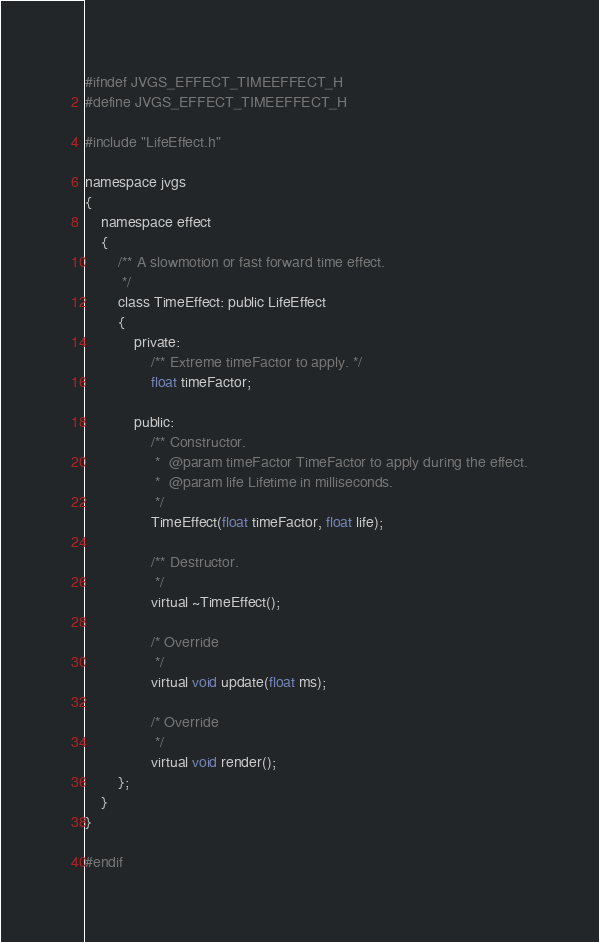<code> <loc_0><loc_0><loc_500><loc_500><_C_>#ifndef JVGS_EFFECT_TIMEEFFECT_H
#define JVGS_EFFECT_TIMEEFFECT_H

#include "LifeEffect.h"

namespace jvgs
{
    namespace effect
    {
        /** A slowmotion or fast forward time effect.
         */
        class TimeEffect: public LifeEffect
        {
            private:
                /** Extreme timeFactor to apply. */
                float timeFactor;

            public:
                /** Constructor.
                 *  @param timeFactor TimeFactor to apply during the effect.
                 *  @param life Lifetime in milliseconds.
                 */
                TimeEffect(float timeFactor, float life);

                /** Destructor.
                 */
                virtual ~TimeEffect();

                /* Override
                 */
                virtual void update(float ms);

                /* Override
                 */
                virtual void render();
        };
    }
}

#endif
</code> 